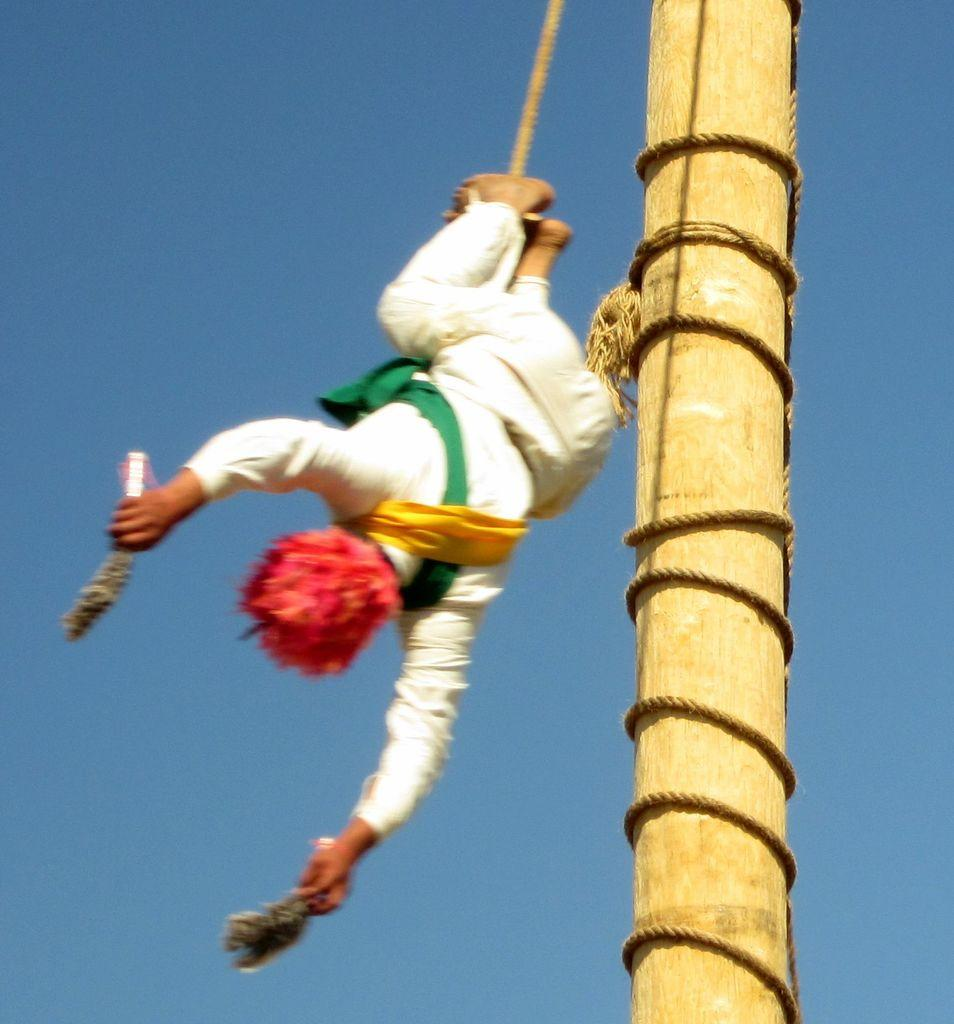What is the main object in the image? There is a wooden pole in the image. What is happening to the person in the image? A person is falling down in the image. How is the person connected to the wooden pole? The person is tied to the wooden pole with a rope. What is the person holding in their hands? The person is holding objects in both hands. What type of owl can be seen flying near the person in the image? There is no owl present in the image. How does the person's loss affect their existence in the image? The image does not depict any loss or existence of the person; it only shows them falling down while tied to a wooden pole. 